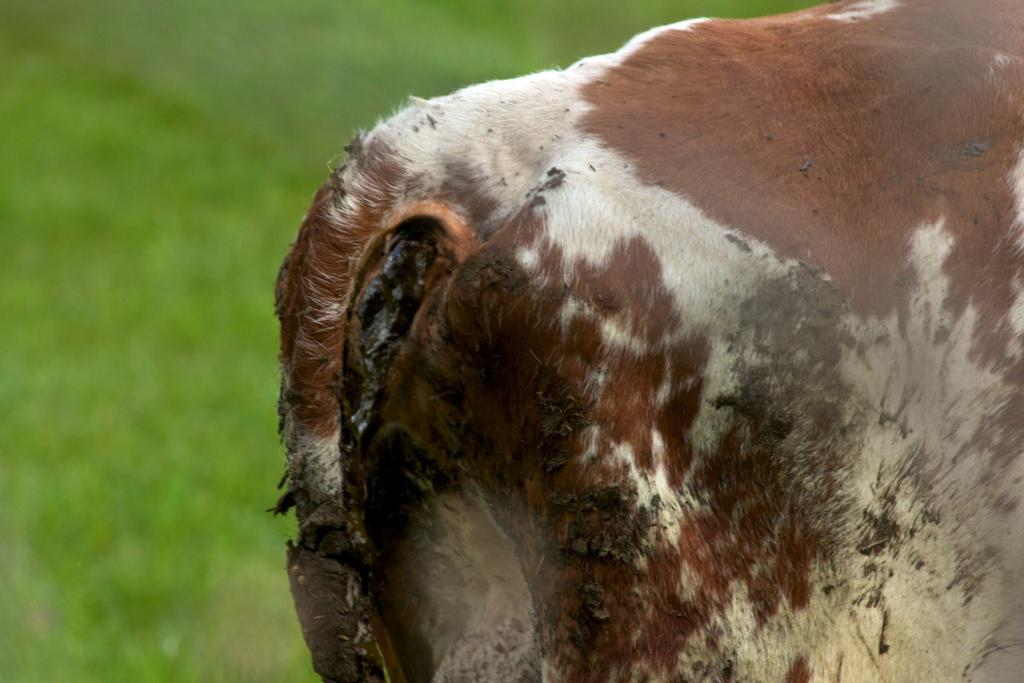What type of animal is in the image? There is a brown and white cow in the image. How is the cow positioned in the image? The cow is viewed from the backside. What can be observed about the background of the image? The background of the image is blurred. What type of authority figure can be seen interacting with the cow in the image? There is no authority figure present in the image; it only features a brown and white cow. How many tomatoes are visible in the image? There are no tomatoes present in the image. 